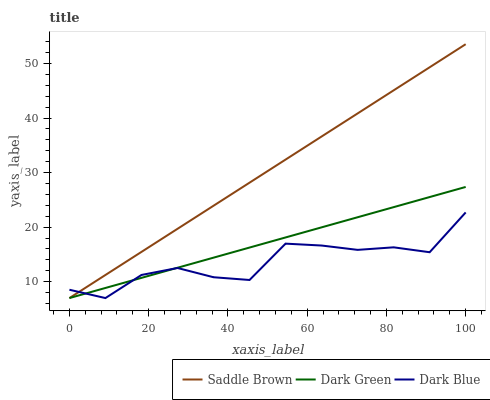Does Dark Blue have the minimum area under the curve?
Answer yes or no. Yes. Does Saddle Brown have the maximum area under the curve?
Answer yes or no. Yes. Does Dark Green have the minimum area under the curve?
Answer yes or no. No. Does Dark Green have the maximum area under the curve?
Answer yes or no. No. Is Dark Green the smoothest?
Answer yes or no. Yes. Is Dark Blue the roughest?
Answer yes or no. Yes. Is Saddle Brown the smoothest?
Answer yes or no. No. Is Saddle Brown the roughest?
Answer yes or no. No. Does Dark Blue have the lowest value?
Answer yes or no. Yes. Does Saddle Brown have the highest value?
Answer yes or no. Yes. Does Dark Green have the highest value?
Answer yes or no. No. Does Dark Blue intersect Saddle Brown?
Answer yes or no. Yes. Is Dark Blue less than Saddle Brown?
Answer yes or no. No. Is Dark Blue greater than Saddle Brown?
Answer yes or no. No. 